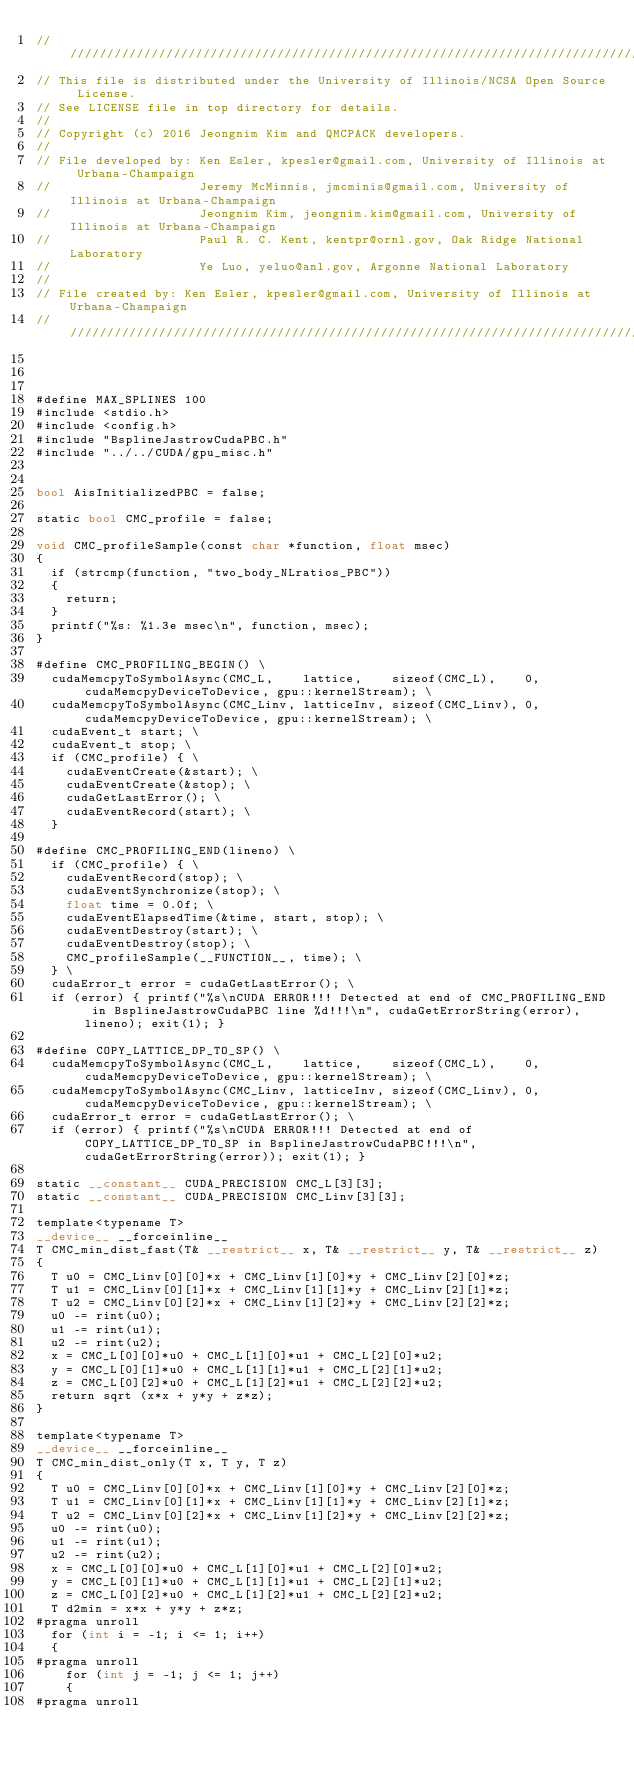Convert code to text. <code><loc_0><loc_0><loc_500><loc_500><_Cuda_>//////////////////////////////////////////////////////////////////////////////////////
// This file is distributed under the University of Illinois/NCSA Open Source License.
// See LICENSE file in top directory for details.
//
// Copyright (c) 2016 Jeongnim Kim and QMCPACK developers.
//
// File developed by: Ken Esler, kpesler@gmail.com, University of Illinois at Urbana-Champaign
//                    Jeremy McMinnis, jmcminis@gmail.com, University of Illinois at Urbana-Champaign
//                    Jeongnim Kim, jeongnim.kim@gmail.com, University of Illinois at Urbana-Champaign
//                    Paul R. C. Kent, kentpr@ornl.gov, Oak Ridge National Laboratory
//                    Ye Luo, yeluo@anl.gov, Argonne National Laboratory
//
// File created by: Ken Esler, kpesler@gmail.com, University of Illinois at Urbana-Champaign
//////////////////////////////////////////////////////////////////////////////////////
    
    

#define MAX_SPLINES 100
#include <stdio.h>
#include <config.h>
#include "BsplineJastrowCudaPBC.h"
#include "../../CUDA/gpu_misc.h"


bool AisInitializedPBC = false;

static bool CMC_profile = false;

void CMC_profileSample(const char *function, float msec)
{
  if (strcmp(function, "two_body_NLratios_PBC"))
  {
    return;
  }
  printf("%s: %1.3e msec\n", function, msec);
}

#define CMC_PROFILING_BEGIN() \
  cudaMemcpyToSymbolAsync(CMC_L,    lattice,    sizeof(CMC_L),    0, cudaMemcpyDeviceToDevice, gpu::kernelStream); \
  cudaMemcpyToSymbolAsync(CMC_Linv, latticeInv, sizeof(CMC_Linv), 0, cudaMemcpyDeviceToDevice, gpu::kernelStream); \
  cudaEvent_t start; \
  cudaEvent_t stop; \
  if (CMC_profile) { \
    cudaEventCreate(&start); \
    cudaEventCreate(&stop); \
    cudaGetLastError(); \
    cudaEventRecord(start); \
  }

#define CMC_PROFILING_END(lineno) \
  if (CMC_profile) { \
    cudaEventRecord(stop); \
    cudaEventSynchronize(stop); \
    float time = 0.0f; \
    cudaEventElapsedTime(&time, start, stop); \
    cudaEventDestroy(start); \
    cudaEventDestroy(stop); \
    CMC_profileSample(__FUNCTION__, time); \
  } \
  cudaError_t error = cudaGetLastError(); \
  if (error) { printf("%s\nCUDA ERROR!!! Detected at end of CMC_PROFILING_END in BsplineJastrowCudaPBC line %d!!!\n", cudaGetErrorString(error), lineno); exit(1); }

#define COPY_LATTICE_DP_TO_SP() \
  cudaMemcpyToSymbolAsync(CMC_L,    lattice,    sizeof(CMC_L),    0, cudaMemcpyDeviceToDevice, gpu::kernelStream); \
  cudaMemcpyToSymbolAsync(CMC_Linv, latticeInv, sizeof(CMC_Linv), 0, cudaMemcpyDeviceToDevice, gpu::kernelStream); \
  cudaError_t error = cudaGetLastError(); \
  if (error) { printf("%s\nCUDA ERROR!!! Detected at end of COPY_LATTICE_DP_TO_SP in BsplineJastrowCudaPBC!!!\n", cudaGetErrorString(error)); exit(1); }

static __constant__ CUDA_PRECISION CMC_L[3][3];
static __constant__ CUDA_PRECISION CMC_Linv[3][3];

template<typename T>
__device__ __forceinline__
T CMC_min_dist_fast(T& __restrict__ x, T& __restrict__ y, T& __restrict__ z)
{
  T u0 = CMC_Linv[0][0]*x + CMC_Linv[1][0]*y + CMC_Linv[2][0]*z;
  T u1 = CMC_Linv[0][1]*x + CMC_Linv[1][1]*y + CMC_Linv[2][1]*z;
  T u2 = CMC_Linv[0][2]*x + CMC_Linv[1][2]*y + CMC_Linv[2][2]*z;
  u0 -= rint(u0);
  u1 -= rint(u1);
  u2 -= rint(u2);
  x = CMC_L[0][0]*u0 + CMC_L[1][0]*u1 + CMC_L[2][0]*u2;
  y = CMC_L[0][1]*u0 + CMC_L[1][1]*u1 + CMC_L[2][1]*u2;
  z = CMC_L[0][2]*u0 + CMC_L[1][2]*u1 + CMC_L[2][2]*u2;
  return sqrt (x*x + y*y + z*z);
}

template<typename T>
__device__ __forceinline__
T CMC_min_dist_only(T x, T y, T z)
{
  T u0 = CMC_Linv[0][0]*x + CMC_Linv[1][0]*y + CMC_Linv[2][0]*z;
  T u1 = CMC_Linv[0][1]*x + CMC_Linv[1][1]*y + CMC_Linv[2][1]*z;
  T u2 = CMC_Linv[0][2]*x + CMC_Linv[1][2]*y + CMC_Linv[2][2]*z;
  u0 -= rint(u0);
  u1 -= rint(u1);
  u2 -= rint(u2);
  x = CMC_L[0][0]*u0 + CMC_L[1][0]*u1 + CMC_L[2][0]*u2;
  y = CMC_L[0][1]*u0 + CMC_L[1][1]*u1 + CMC_L[2][1]*u2;
  z = CMC_L[0][2]*u0 + CMC_L[1][2]*u1 + CMC_L[2][2]*u2;
  T d2min = x*x + y*y + z*z;
#pragma unroll
  for (int i = -1; i <= 1; i++)
  {
#pragma unroll
    for (int j = -1; j <= 1; j++)
    {
#pragma unroll</code> 